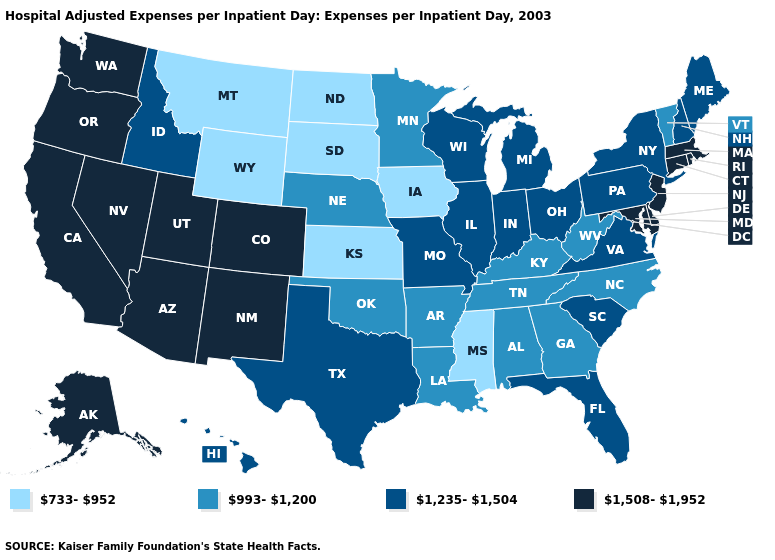Does the first symbol in the legend represent the smallest category?
Be succinct. Yes. Name the states that have a value in the range 733-952?
Quick response, please. Iowa, Kansas, Mississippi, Montana, North Dakota, South Dakota, Wyoming. What is the value of Oklahoma?
Quick response, please. 993-1,200. Does Washington have the highest value in the West?
Keep it brief. Yes. Does Texas have the highest value in the USA?
Quick response, please. No. What is the lowest value in the MidWest?
Give a very brief answer. 733-952. Name the states that have a value in the range 1,508-1,952?
Quick response, please. Alaska, Arizona, California, Colorado, Connecticut, Delaware, Maryland, Massachusetts, Nevada, New Jersey, New Mexico, Oregon, Rhode Island, Utah, Washington. Name the states that have a value in the range 733-952?
Write a very short answer. Iowa, Kansas, Mississippi, Montana, North Dakota, South Dakota, Wyoming. Name the states that have a value in the range 733-952?
Quick response, please. Iowa, Kansas, Mississippi, Montana, North Dakota, South Dakota, Wyoming. Does Oklahoma have a lower value than Arizona?
Short answer required. Yes. How many symbols are there in the legend?
Give a very brief answer. 4. Among the states that border Kentucky , which have the lowest value?
Short answer required. Tennessee, West Virginia. What is the value of Georgia?
Give a very brief answer. 993-1,200. Name the states that have a value in the range 733-952?
Be succinct. Iowa, Kansas, Mississippi, Montana, North Dakota, South Dakota, Wyoming. How many symbols are there in the legend?
Concise answer only. 4. 